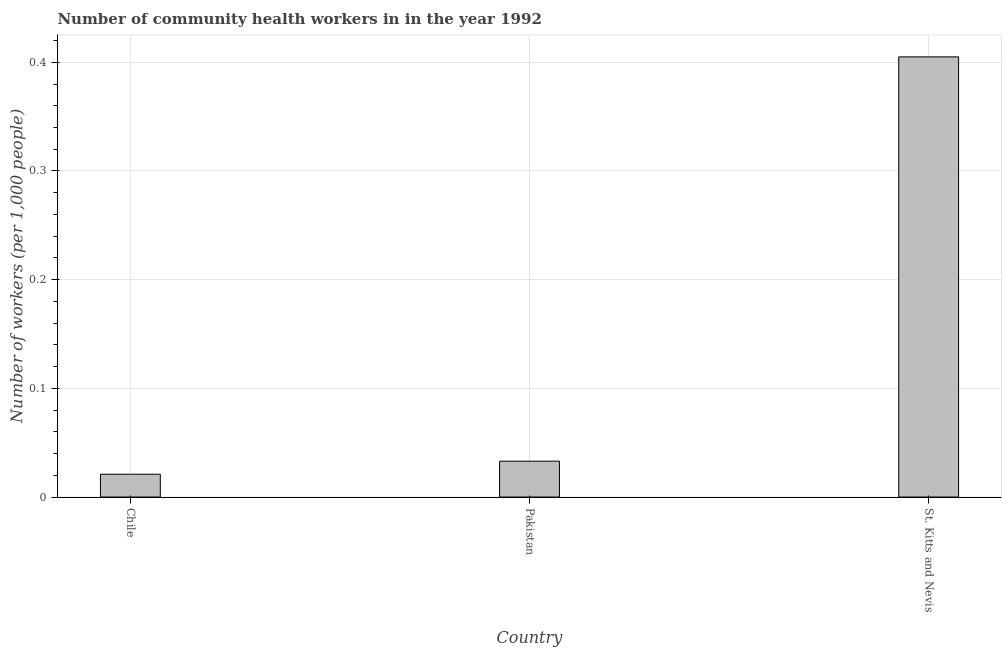What is the title of the graph?
Your response must be concise. Number of community health workers in in the year 1992. What is the label or title of the X-axis?
Your answer should be compact. Country. What is the label or title of the Y-axis?
Offer a very short reply. Number of workers (per 1,0 people). What is the number of community health workers in Chile?
Make the answer very short. 0.02. Across all countries, what is the maximum number of community health workers?
Ensure brevity in your answer.  0.41. Across all countries, what is the minimum number of community health workers?
Your response must be concise. 0.02. In which country was the number of community health workers maximum?
Give a very brief answer. St. Kitts and Nevis. What is the sum of the number of community health workers?
Ensure brevity in your answer.  0.46. What is the difference between the number of community health workers in Chile and St. Kitts and Nevis?
Your response must be concise. -0.38. What is the average number of community health workers per country?
Provide a succinct answer. 0.15. What is the median number of community health workers?
Ensure brevity in your answer.  0.03. What is the ratio of the number of community health workers in Chile to that in Pakistan?
Ensure brevity in your answer.  0.64. Is the number of community health workers in Pakistan less than that in St. Kitts and Nevis?
Provide a short and direct response. Yes. Is the difference between the number of community health workers in Pakistan and St. Kitts and Nevis greater than the difference between any two countries?
Give a very brief answer. No. What is the difference between the highest and the second highest number of community health workers?
Provide a succinct answer. 0.37. Is the sum of the number of community health workers in Chile and St. Kitts and Nevis greater than the maximum number of community health workers across all countries?
Offer a very short reply. Yes. What is the difference between the highest and the lowest number of community health workers?
Your answer should be compact. 0.38. In how many countries, is the number of community health workers greater than the average number of community health workers taken over all countries?
Offer a terse response. 1. How many bars are there?
Provide a succinct answer. 3. Are all the bars in the graph horizontal?
Offer a terse response. No. How many countries are there in the graph?
Your response must be concise. 3. Are the values on the major ticks of Y-axis written in scientific E-notation?
Offer a very short reply. No. What is the Number of workers (per 1,000 people) in Chile?
Your response must be concise. 0.02. What is the Number of workers (per 1,000 people) in Pakistan?
Keep it short and to the point. 0.03. What is the Number of workers (per 1,000 people) of St. Kitts and Nevis?
Offer a terse response. 0.41. What is the difference between the Number of workers (per 1,000 people) in Chile and Pakistan?
Your response must be concise. -0.01. What is the difference between the Number of workers (per 1,000 people) in Chile and St. Kitts and Nevis?
Your answer should be compact. -0.38. What is the difference between the Number of workers (per 1,000 people) in Pakistan and St. Kitts and Nevis?
Your response must be concise. -0.37. What is the ratio of the Number of workers (per 1,000 people) in Chile to that in Pakistan?
Your response must be concise. 0.64. What is the ratio of the Number of workers (per 1,000 people) in Chile to that in St. Kitts and Nevis?
Give a very brief answer. 0.05. What is the ratio of the Number of workers (per 1,000 people) in Pakistan to that in St. Kitts and Nevis?
Offer a terse response. 0.08. 